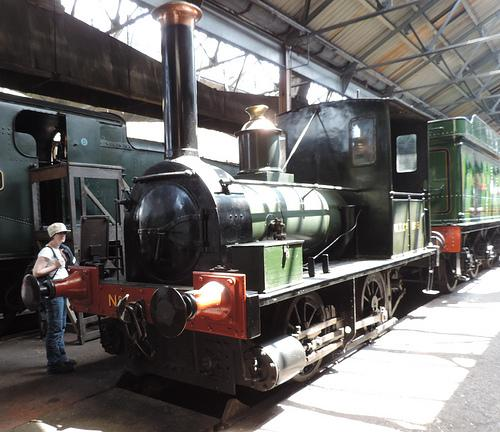Write a caption encompassing the essence of the image. Youth admiring a vibrant, antique steam engine train and its components. In one sentence, describe the focal point of the picture. The focus of the image is a young person observing a colorful, old-fashioned train. Mention the primary activity shown in the image. A person is looking at a multicolored old-fashioned steam engine train. Provide a brief description of the primary focus of the image. A boy wearing a white hat and blue jeans is watching an antique train with multiple colors. Sum up the image in a short statement. Boy intrigued by an antique train with vivid colors and intricate components. Give a brief account of the significant elements in the picture. A young onlooker wearing a hat examines a historic train with multiple colors and details. Using different words, describe the central action in the image. A youth donning a cap gazes at a vintage locomotive with multiple hues. Describe the main components and subjects in the image. A boy in white hat and jeans, various train parts, and an antique multicolored locomotive. Explain the main event captured in the image. In the picture, a young individual wearing a hat observes a historical train with fascination. Create a concise visual summary of the image. Boy in blue jeans observing an antique, colorful train with various objects and parts. 